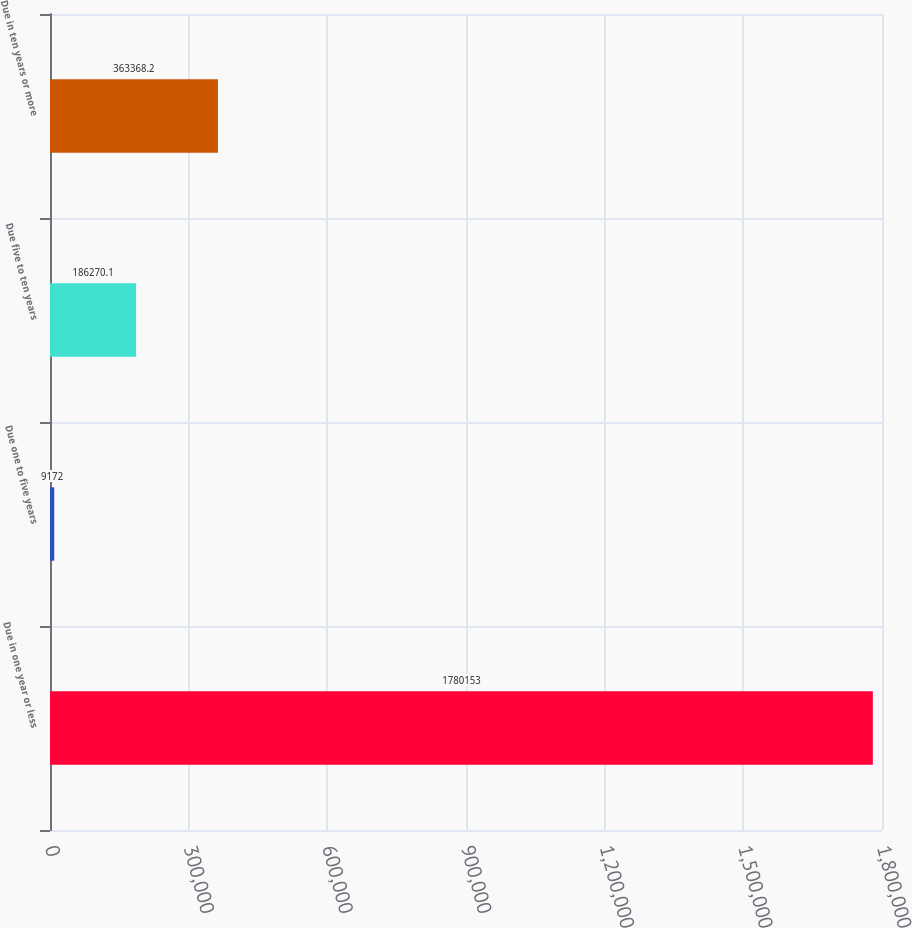Convert chart. <chart><loc_0><loc_0><loc_500><loc_500><bar_chart><fcel>Due in one year or less<fcel>Due one to five years<fcel>Due five to ten years<fcel>Due in ten years or more<nl><fcel>1.78015e+06<fcel>9172<fcel>186270<fcel>363368<nl></chart> 